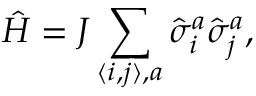Convert formula to latex. <formula><loc_0><loc_0><loc_500><loc_500>\hat { H } = J \sum _ { \langle i , j \rangle , a } \hat { \sigma } _ { i } ^ { a } \hat { \sigma } _ { j } ^ { a } ,</formula> 